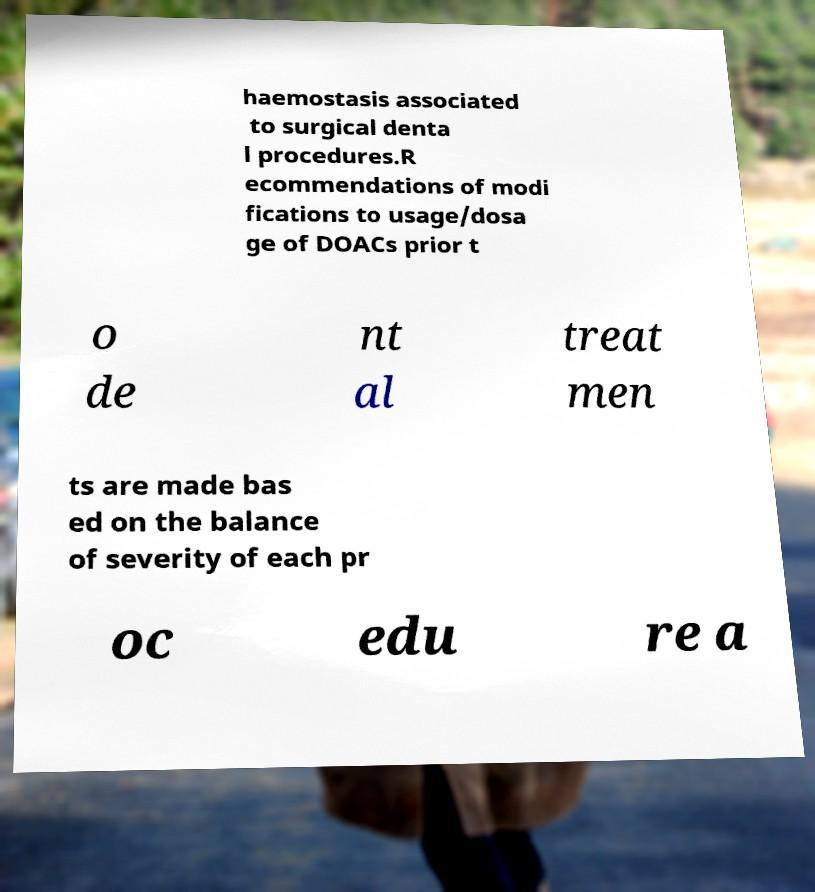Please identify and transcribe the text found in this image. haemostasis associated to surgical denta l procedures.R ecommendations of modi fications to usage/dosa ge of DOACs prior t o de nt al treat men ts are made bas ed on the balance of severity of each pr oc edu re a 